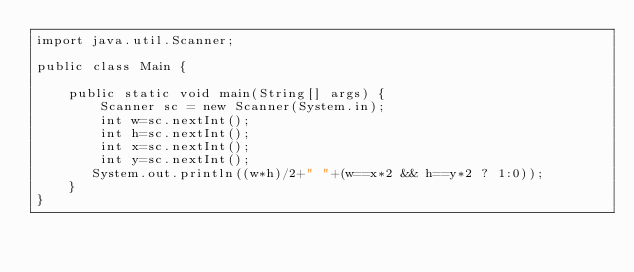Convert code to text. <code><loc_0><loc_0><loc_500><loc_500><_Java_>import java.util.Scanner;

public class Main {

    public static void main(String[] args) {
        Scanner sc = new Scanner(System.in);
        int w=sc.nextInt();
        int h=sc.nextInt();
        int x=sc.nextInt();
        int y=sc.nextInt();
       System.out.println((w*h)/2+" "+(w==x*2 && h==y*2 ? 1:0));
    }
}
</code> 